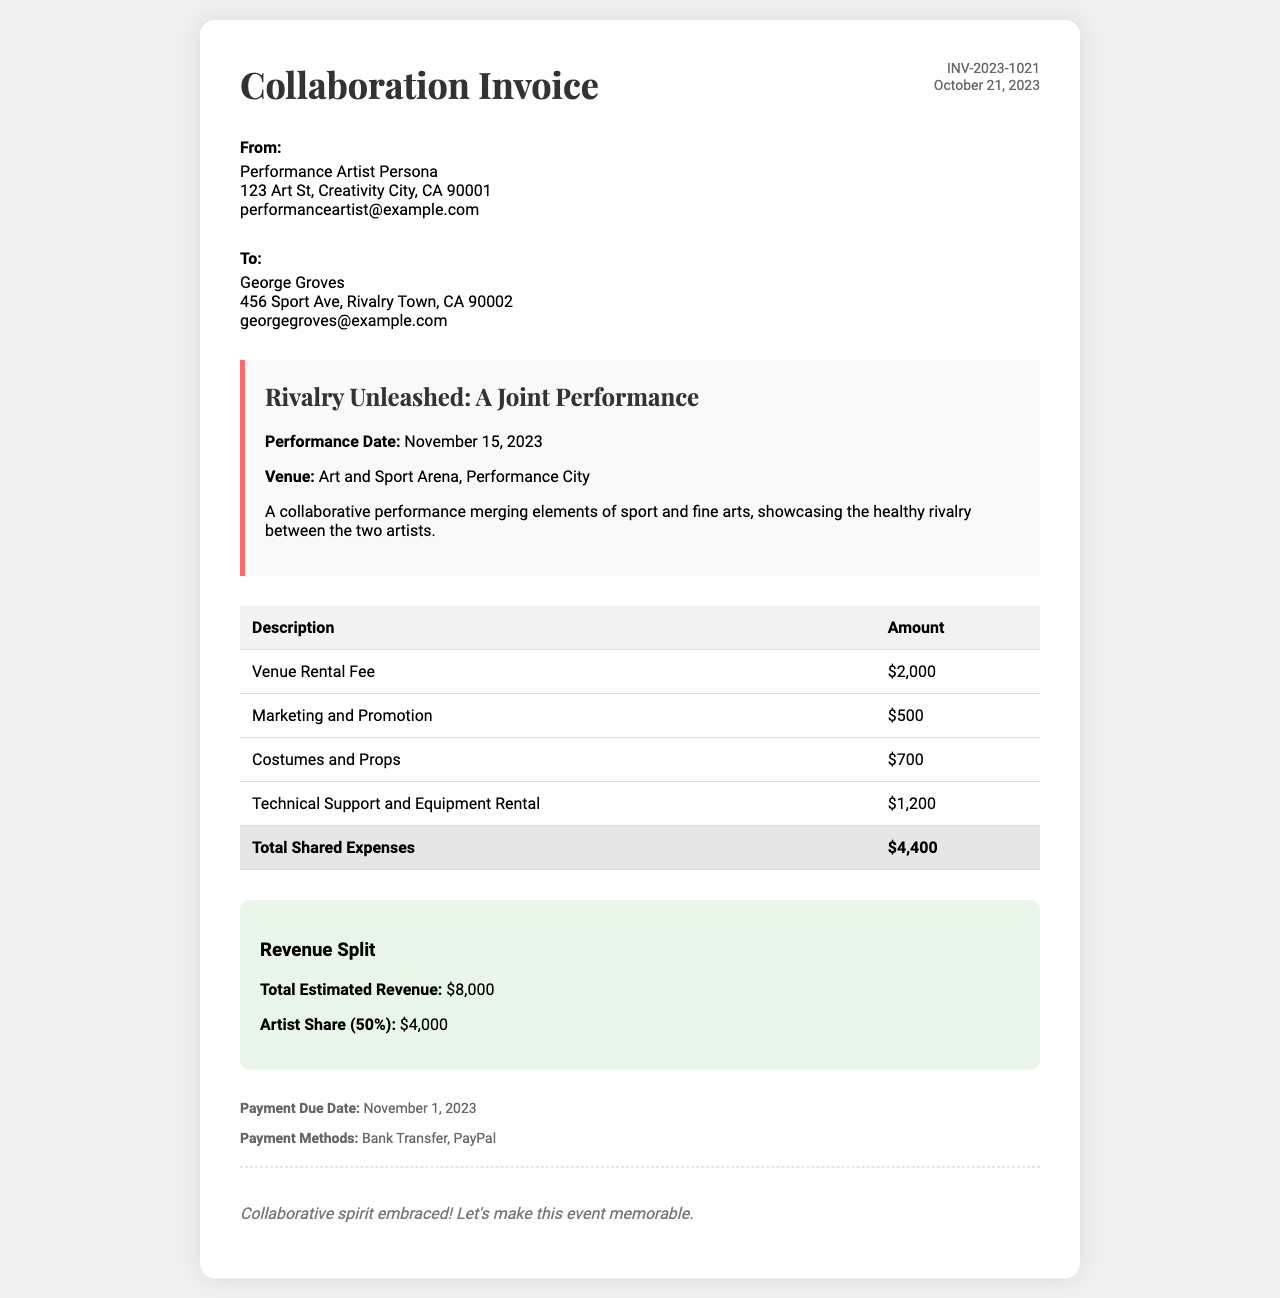what is the invoice number? The invoice number is stated in the document under the invoice details section.
Answer: INV-2023-1021 what is the performance date? The performance date is listed in the project details section of the invoice.
Answer: November 15, 2023 what is the total shared expenses? The total shared expenses is summarized in the table at the bottom of the expense section.
Answer: $4,400 who is the invoice addressed to? The invoice specifies the recipient in the address block section.
Answer: George Groves what is the venue for the performance? The venue is mentioned in the project details on the invoice.
Answer: Art and Sport Arena, Performance City what is the total estimated revenue? The total estimated revenue is provided in the revenue split section.
Answer: $8,000 what is the payment due date? The payment due date can be found in the payment terms section of the document.
Answer: November 1, 2023 what is the artist share percentage? The artist share percentage is indicated in the revenue split section of the invoice.
Answer: 50% what is included in the expenses for costumes and props? The line item for costumes and props is detailed in the expenses table of the invoice.
Answer: $700 